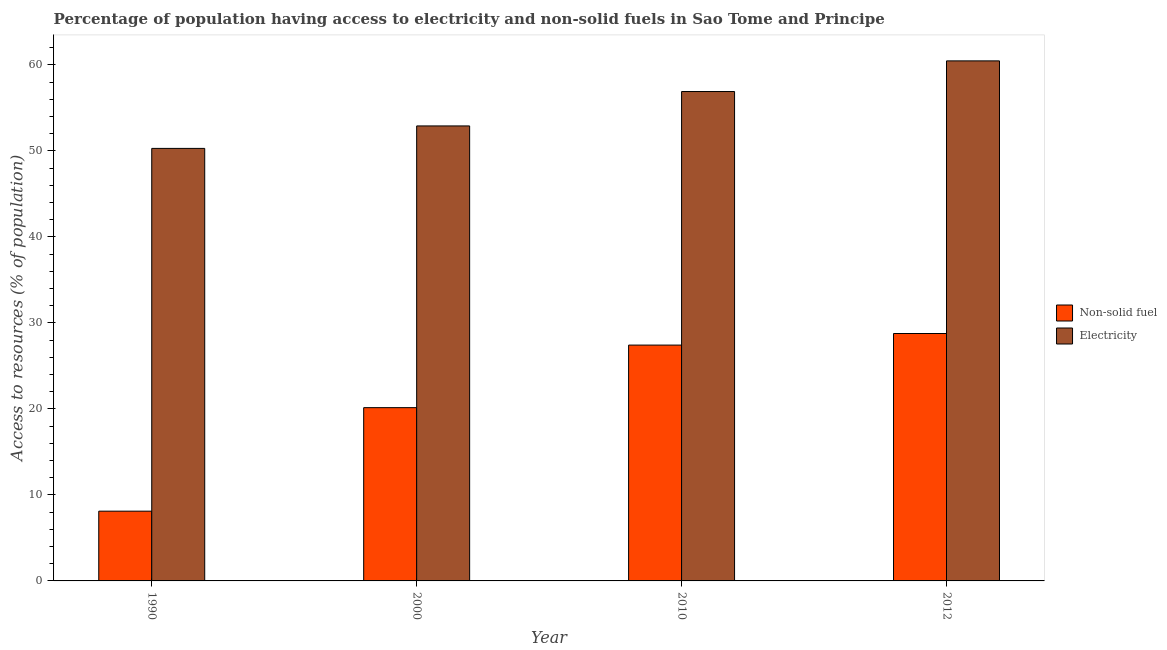How many different coloured bars are there?
Keep it short and to the point. 2. How many groups of bars are there?
Offer a terse response. 4. Are the number of bars on each tick of the X-axis equal?
Your response must be concise. Yes. In how many cases, is the number of bars for a given year not equal to the number of legend labels?
Your answer should be compact. 0. What is the percentage of population having access to electricity in 1990?
Provide a succinct answer. 50.29. Across all years, what is the maximum percentage of population having access to electricity?
Your answer should be very brief. 60.46. Across all years, what is the minimum percentage of population having access to non-solid fuel?
Offer a terse response. 8.11. In which year was the percentage of population having access to electricity maximum?
Provide a short and direct response. 2012. In which year was the percentage of population having access to non-solid fuel minimum?
Your answer should be very brief. 1990. What is the total percentage of population having access to electricity in the graph?
Your answer should be compact. 220.55. What is the difference between the percentage of population having access to non-solid fuel in 2010 and that in 2012?
Make the answer very short. -1.35. What is the difference between the percentage of population having access to electricity in 1990 and the percentage of population having access to non-solid fuel in 2000?
Keep it short and to the point. -2.61. What is the average percentage of population having access to non-solid fuel per year?
Make the answer very short. 21.11. What is the ratio of the percentage of population having access to electricity in 2010 to that in 2012?
Provide a short and direct response. 0.94. Is the percentage of population having access to electricity in 1990 less than that in 2000?
Offer a very short reply. Yes. Is the difference between the percentage of population having access to electricity in 1990 and 2000 greater than the difference between the percentage of population having access to non-solid fuel in 1990 and 2000?
Keep it short and to the point. No. What is the difference between the highest and the second highest percentage of population having access to non-solid fuel?
Give a very brief answer. 1.35. What is the difference between the highest and the lowest percentage of population having access to non-solid fuel?
Offer a terse response. 20.65. In how many years, is the percentage of population having access to non-solid fuel greater than the average percentage of population having access to non-solid fuel taken over all years?
Ensure brevity in your answer.  2. Is the sum of the percentage of population having access to electricity in 1990 and 2000 greater than the maximum percentage of population having access to non-solid fuel across all years?
Your answer should be very brief. Yes. What does the 1st bar from the left in 2000 represents?
Keep it short and to the point. Non-solid fuel. What does the 2nd bar from the right in 1990 represents?
Your response must be concise. Non-solid fuel. How many bars are there?
Keep it short and to the point. 8. Are all the bars in the graph horizontal?
Your answer should be compact. No. How many years are there in the graph?
Provide a short and direct response. 4. Are the values on the major ticks of Y-axis written in scientific E-notation?
Provide a succinct answer. No. Does the graph contain grids?
Provide a succinct answer. No. How many legend labels are there?
Ensure brevity in your answer.  2. What is the title of the graph?
Keep it short and to the point. Percentage of population having access to electricity and non-solid fuels in Sao Tome and Principe. Does "Money lenders" appear as one of the legend labels in the graph?
Your answer should be compact. No. What is the label or title of the X-axis?
Your answer should be very brief. Year. What is the label or title of the Y-axis?
Your answer should be compact. Access to resources (% of population). What is the Access to resources (% of population) of Non-solid fuel in 1990?
Keep it short and to the point. 8.11. What is the Access to resources (% of population) of Electricity in 1990?
Your answer should be very brief. 50.29. What is the Access to resources (% of population) of Non-solid fuel in 2000?
Your answer should be compact. 20.14. What is the Access to resources (% of population) in Electricity in 2000?
Ensure brevity in your answer.  52.9. What is the Access to resources (% of population) in Non-solid fuel in 2010?
Make the answer very short. 27.42. What is the Access to resources (% of population) in Electricity in 2010?
Ensure brevity in your answer.  56.9. What is the Access to resources (% of population) in Non-solid fuel in 2012?
Offer a very short reply. 28.77. What is the Access to resources (% of population) of Electricity in 2012?
Give a very brief answer. 60.46. Across all years, what is the maximum Access to resources (% of population) of Non-solid fuel?
Offer a terse response. 28.77. Across all years, what is the maximum Access to resources (% of population) of Electricity?
Provide a succinct answer. 60.46. Across all years, what is the minimum Access to resources (% of population) of Non-solid fuel?
Your response must be concise. 8.11. Across all years, what is the minimum Access to resources (% of population) in Electricity?
Offer a very short reply. 50.29. What is the total Access to resources (% of population) of Non-solid fuel in the graph?
Make the answer very short. 84.44. What is the total Access to resources (% of population) of Electricity in the graph?
Provide a short and direct response. 220.55. What is the difference between the Access to resources (% of population) in Non-solid fuel in 1990 and that in 2000?
Offer a terse response. -12.03. What is the difference between the Access to resources (% of population) in Electricity in 1990 and that in 2000?
Your answer should be very brief. -2.61. What is the difference between the Access to resources (% of population) of Non-solid fuel in 1990 and that in 2010?
Your response must be concise. -19.31. What is the difference between the Access to resources (% of population) of Electricity in 1990 and that in 2010?
Make the answer very short. -6.61. What is the difference between the Access to resources (% of population) in Non-solid fuel in 1990 and that in 2012?
Your answer should be very brief. -20.65. What is the difference between the Access to resources (% of population) in Electricity in 1990 and that in 2012?
Offer a terse response. -10.17. What is the difference between the Access to resources (% of population) of Non-solid fuel in 2000 and that in 2010?
Give a very brief answer. -7.27. What is the difference between the Access to resources (% of population) of Non-solid fuel in 2000 and that in 2012?
Your answer should be compact. -8.62. What is the difference between the Access to resources (% of population) of Electricity in 2000 and that in 2012?
Make the answer very short. -7.56. What is the difference between the Access to resources (% of population) of Non-solid fuel in 2010 and that in 2012?
Provide a short and direct response. -1.35. What is the difference between the Access to resources (% of population) of Electricity in 2010 and that in 2012?
Keep it short and to the point. -3.56. What is the difference between the Access to resources (% of population) of Non-solid fuel in 1990 and the Access to resources (% of population) of Electricity in 2000?
Make the answer very short. -44.79. What is the difference between the Access to resources (% of population) of Non-solid fuel in 1990 and the Access to resources (% of population) of Electricity in 2010?
Make the answer very short. -48.79. What is the difference between the Access to resources (% of population) in Non-solid fuel in 1990 and the Access to resources (% of population) in Electricity in 2012?
Provide a succinct answer. -52.35. What is the difference between the Access to resources (% of population) in Non-solid fuel in 2000 and the Access to resources (% of population) in Electricity in 2010?
Your response must be concise. -36.76. What is the difference between the Access to resources (% of population) of Non-solid fuel in 2000 and the Access to resources (% of population) of Electricity in 2012?
Keep it short and to the point. -40.32. What is the difference between the Access to resources (% of population) in Non-solid fuel in 2010 and the Access to resources (% of population) in Electricity in 2012?
Make the answer very short. -33.04. What is the average Access to resources (% of population) of Non-solid fuel per year?
Your answer should be very brief. 21.11. What is the average Access to resources (% of population) of Electricity per year?
Offer a terse response. 55.14. In the year 1990, what is the difference between the Access to resources (% of population) of Non-solid fuel and Access to resources (% of population) of Electricity?
Your response must be concise. -42.18. In the year 2000, what is the difference between the Access to resources (% of population) in Non-solid fuel and Access to resources (% of population) in Electricity?
Provide a short and direct response. -32.76. In the year 2010, what is the difference between the Access to resources (% of population) in Non-solid fuel and Access to resources (% of population) in Electricity?
Give a very brief answer. -29.48. In the year 2012, what is the difference between the Access to resources (% of population) of Non-solid fuel and Access to resources (% of population) of Electricity?
Provide a short and direct response. -31.7. What is the ratio of the Access to resources (% of population) in Non-solid fuel in 1990 to that in 2000?
Your answer should be very brief. 0.4. What is the ratio of the Access to resources (% of population) in Electricity in 1990 to that in 2000?
Your answer should be compact. 0.95. What is the ratio of the Access to resources (% of population) in Non-solid fuel in 1990 to that in 2010?
Make the answer very short. 0.3. What is the ratio of the Access to resources (% of population) of Electricity in 1990 to that in 2010?
Make the answer very short. 0.88. What is the ratio of the Access to resources (% of population) in Non-solid fuel in 1990 to that in 2012?
Your response must be concise. 0.28. What is the ratio of the Access to resources (% of population) of Electricity in 1990 to that in 2012?
Make the answer very short. 0.83. What is the ratio of the Access to resources (% of population) of Non-solid fuel in 2000 to that in 2010?
Make the answer very short. 0.73. What is the ratio of the Access to resources (% of population) in Electricity in 2000 to that in 2010?
Offer a terse response. 0.93. What is the ratio of the Access to resources (% of population) in Non-solid fuel in 2000 to that in 2012?
Your response must be concise. 0.7. What is the ratio of the Access to resources (% of population) of Electricity in 2000 to that in 2012?
Give a very brief answer. 0.87. What is the ratio of the Access to resources (% of population) in Non-solid fuel in 2010 to that in 2012?
Your answer should be compact. 0.95. What is the ratio of the Access to resources (% of population) of Electricity in 2010 to that in 2012?
Ensure brevity in your answer.  0.94. What is the difference between the highest and the second highest Access to resources (% of population) in Non-solid fuel?
Make the answer very short. 1.35. What is the difference between the highest and the second highest Access to resources (% of population) in Electricity?
Your answer should be very brief. 3.56. What is the difference between the highest and the lowest Access to resources (% of population) in Non-solid fuel?
Your answer should be very brief. 20.65. What is the difference between the highest and the lowest Access to resources (% of population) of Electricity?
Keep it short and to the point. 10.17. 